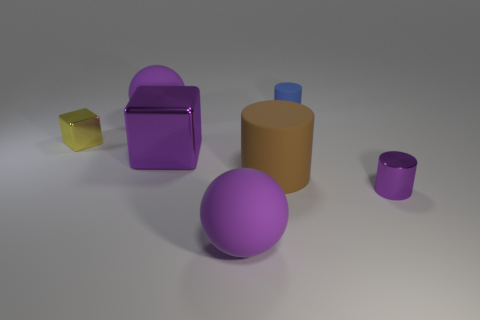What is the shape of the tiny thing that is the same color as the large block?
Your response must be concise. Cylinder. What number of yellow things are either blocks or small metallic cylinders?
Keep it short and to the point. 1. Is the shape of the big object that is behind the tiny cube the same as  the large brown thing?
Your answer should be compact. No. Are there more purple blocks that are behind the small blue cylinder than green matte blocks?
Make the answer very short. No. What number of metallic things are the same size as the purple block?
Your response must be concise. 0. There is a cylinder that is the same color as the large metallic cube; what is its size?
Offer a very short reply. Small. What number of objects are either metal blocks or metallic things on the right side of the tiny blue rubber cylinder?
Make the answer very short. 3. What is the color of the rubber thing that is in front of the tiny block and behind the purple cylinder?
Your answer should be compact. Brown. Is the size of the blue rubber cylinder the same as the yellow metallic object?
Ensure brevity in your answer.  Yes. What color is the small metallic object that is behind the small purple object?
Give a very brief answer. Yellow. 